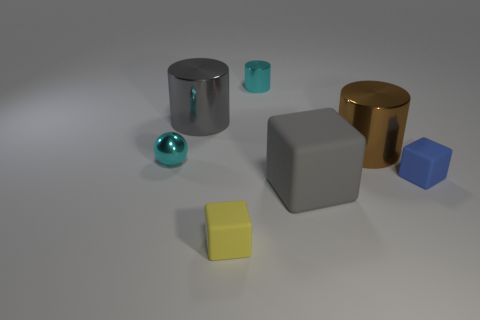What is the size of the brown thing that is made of the same material as the tiny sphere?
Make the answer very short. Large. There is a metal cylinder that is the same color as the big cube; what is its size?
Your answer should be compact. Large. Is the small cylinder the same color as the sphere?
Provide a short and direct response. Yes. Is there a big object in front of the big shiny cylinder that is in front of the gray thing left of the gray cube?
Make the answer very short. Yes. What number of spheres are the same size as the yellow matte object?
Keep it short and to the point. 1. Does the matte object to the right of the big brown thing have the same size as the ball to the left of the large gray block?
Your answer should be compact. Yes. The object that is both in front of the brown shiny cylinder and to the right of the large rubber cube has what shape?
Make the answer very short. Cube. Are there any small cylinders of the same color as the metal ball?
Offer a terse response. Yes. Are there any big blue metal things?
Keep it short and to the point. No. There is a tiny metallic thing that is right of the ball; what color is it?
Your response must be concise. Cyan. 